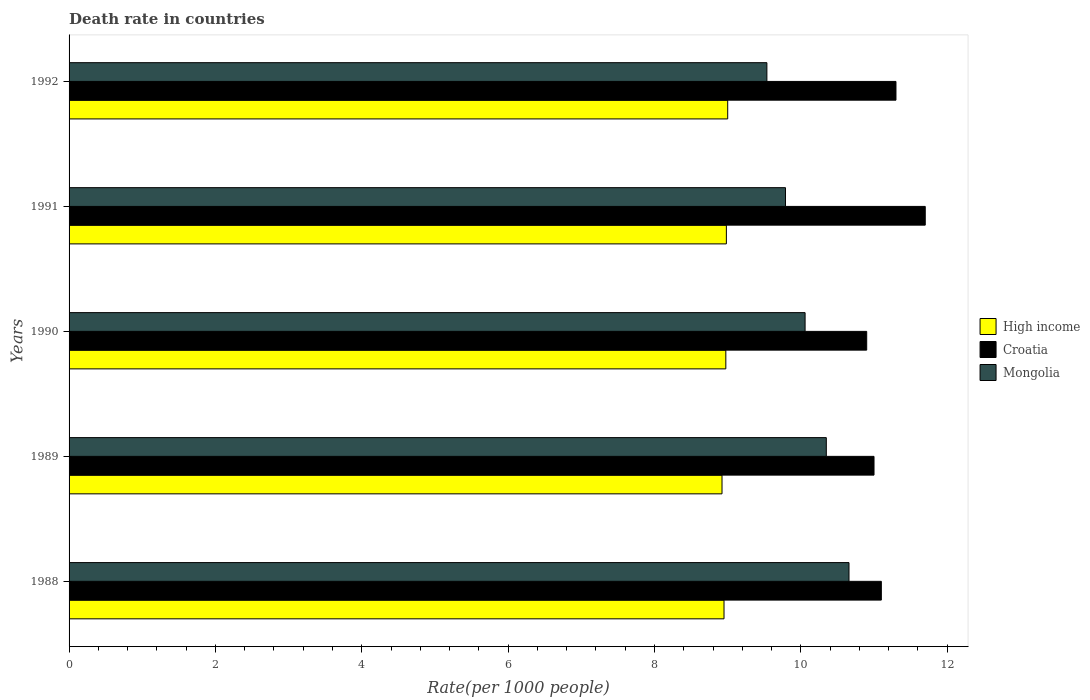How many different coloured bars are there?
Your response must be concise. 3. Are the number of bars per tick equal to the number of legend labels?
Keep it short and to the point. Yes. Are the number of bars on each tick of the Y-axis equal?
Ensure brevity in your answer.  Yes. How many bars are there on the 3rd tick from the top?
Ensure brevity in your answer.  3. How many bars are there on the 1st tick from the bottom?
Provide a succinct answer. 3. What is the label of the 1st group of bars from the top?
Provide a short and direct response. 1992. In how many cases, is the number of bars for a given year not equal to the number of legend labels?
Offer a terse response. 0. What is the death rate in Mongolia in 1992?
Ensure brevity in your answer.  9.54. Across all years, what is the maximum death rate in High income?
Your answer should be compact. 9. Across all years, what is the minimum death rate in Croatia?
Keep it short and to the point. 10.9. In which year was the death rate in Croatia maximum?
Provide a short and direct response. 1991. In which year was the death rate in Croatia minimum?
Keep it short and to the point. 1990. What is the total death rate in High income in the graph?
Make the answer very short. 44.83. What is the difference between the death rate in High income in 1988 and that in 1991?
Provide a short and direct response. -0.03. What is the difference between the death rate in Mongolia in 1990 and the death rate in High income in 1991?
Ensure brevity in your answer.  1.08. What is the average death rate in Mongolia per year?
Make the answer very short. 10.08. In the year 1988, what is the difference between the death rate in High income and death rate in Croatia?
Offer a terse response. -2.15. What is the ratio of the death rate in Mongolia in 1988 to that in 1991?
Your answer should be very brief. 1.09. What is the difference between the highest and the second highest death rate in Croatia?
Provide a short and direct response. 0.4. What is the difference between the highest and the lowest death rate in Croatia?
Make the answer very short. 0.8. In how many years, is the death rate in High income greater than the average death rate in High income taken over all years?
Ensure brevity in your answer.  3. What does the 1st bar from the top in 1990 represents?
Provide a short and direct response. Mongolia. What does the 3rd bar from the bottom in 1992 represents?
Make the answer very short. Mongolia. How many bars are there?
Your response must be concise. 15. How many years are there in the graph?
Your answer should be very brief. 5. What is the difference between two consecutive major ticks on the X-axis?
Your answer should be very brief. 2. Are the values on the major ticks of X-axis written in scientific E-notation?
Your answer should be compact. No. Does the graph contain any zero values?
Ensure brevity in your answer.  No. What is the title of the graph?
Keep it short and to the point. Death rate in countries. What is the label or title of the X-axis?
Ensure brevity in your answer.  Rate(per 1000 people). What is the label or title of the Y-axis?
Your answer should be very brief. Years. What is the Rate(per 1000 people) of High income in 1988?
Provide a succinct answer. 8.95. What is the Rate(per 1000 people) of Mongolia in 1988?
Provide a succinct answer. 10.66. What is the Rate(per 1000 people) of High income in 1989?
Provide a succinct answer. 8.92. What is the Rate(per 1000 people) in Croatia in 1989?
Offer a terse response. 11. What is the Rate(per 1000 people) of Mongolia in 1989?
Your answer should be compact. 10.35. What is the Rate(per 1000 people) in High income in 1990?
Ensure brevity in your answer.  8.97. What is the Rate(per 1000 people) of Mongolia in 1990?
Offer a terse response. 10.06. What is the Rate(per 1000 people) of High income in 1991?
Your answer should be compact. 8.98. What is the Rate(per 1000 people) in Mongolia in 1991?
Your answer should be very brief. 9.79. What is the Rate(per 1000 people) of High income in 1992?
Provide a succinct answer. 9. What is the Rate(per 1000 people) in Mongolia in 1992?
Provide a succinct answer. 9.54. Across all years, what is the maximum Rate(per 1000 people) in High income?
Give a very brief answer. 9. Across all years, what is the maximum Rate(per 1000 people) in Mongolia?
Offer a terse response. 10.66. Across all years, what is the minimum Rate(per 1000 people) in High income?
Your answer should be compact. 8.92. Across all years, what is the minimum Rate(per 1000 people) of Mongolia?
Ensure brevity in your answer.  9.54. What is the total Rate(per 1000 people) in High income in the graph?
Your response must be concise. 44.83. What is the total Rate(per 1000 people) in Croatia in the graph?
Offer a terse response. 56. What is the total Rate(per 1000 people) of Mongolia in the graph?
Your answer should be compact. 50.39. What is the difference between the Rate(per 1000 people) of High income in 1988 and that in 1989?
Provide a succinct answer. 0.03. What is the difference between the Rate(per 1000 people) in Croatia in 1988 and that in 1989?
Offer a terse response. 0.1. What is the difference between the Rate(per 1000 people) in Mongolia in 1988 and that in 1989?
Provide a short and direct response. 0.31. What is the difference between the Rate(per 1000 people) of High income in 1988 and that in 1990?
Provide a succinct answer. -0.02. What is the difference between the Rate(per 1000 people) in Mongolia in 1988 and that in 1990?
Offer a very short reply. 0.6. What is the difference between the Rate(per 1000 people) of High income in 1988 and that in 1991?
Your answer should be very brief. -0.03. What is the difference between the Rate(per 1000 people) of Croatia in 1988 and that in 1991?
Your answer should be very brief. -0.6. What is the difference between the Rate(per 1000 people) of Mongolia in 1988 and that in 1991?
Ensure brevity in your answer.  0.87. What is the difference between the Rate(per 1000 people) in High income in 1988 and that in 1992?
Your answer should be compact. -0.05. What is the difference between the Rate(per 1000 people) in Croatia in 1988 and that in 1992?
Your answer should be very brief. -0.2. What is the difference between the Rate(per 1000 people) in Mongolia in 1988 and that in 1992?
Your answer should be compact. 1.12. What is the difference between the Rate(per 1000 people) of High income in 1989 and that in 1990?
Your response must be concise. -0.05. What is the difference between the Rate(per 1000 people) in Mongolia in 1989 and that in 1990?
Make the answer very short. 0.29. What is the difference between the Rate(per 1000 people) in High income in 1989 and that in 1991?
Offer a very short reply. -0.06. What is the difference between the Rate(per 1000 people) in Mongolia in 1989 and that in 1991?
Ensure brevity in your answer.  0.56. What is the difference between the Rate(per 1000 people) of High income in 1989 and that in 1992?
Keep it short and to the point. -0.08. What is the difference between the Rate(per 1000 people) in Mongolia in 1989 and that in 1992?
Offer a very short reply. 0.81. What is the difference between the Rate(per 1000 people) in High income in 1990 and that in 1991?
Your answer should be compact. -0.01. What is the difference between the Rate(per 1000 people) of Croatia in 1990 and that in 1991?
Provide a succinct answer. -0.8. What is the difference between the Rate(per 1000 people) in Mongolia in 1990 and that in 1991?
Your response must be concise. 0.27. What is the difference between the Rate(per 1000 people) of High income in 1990 and that in 1992?
Make the answer very short. -0.03. What is the difference between the Rate(per 1000 people) of Croatia in 1990 and that in 1992?
Ensure brevity in your answer.  -0.4. What is the difference between the Rate(per 1000 people) of Mongolia in 1990 and that in 1992?
Make the answer very short. 0.52. What is the difference between the Rate(per 1000 people) in High income in 1991 and that in 1992?
Give a very brief answer. -0.02. What is the difference between the Rate(per 1000 people) in Mongolia in 1991 and that in 1992?
Make the answer very short. 0.25. What is the difference between the Rate(per 1000 people) of High income in 1988 and the Rate(per 1000 people) of Croatia in 1989?
Offer a terse response. -2.05. What is the difference between the Rate(per 1000 people) in High income in 1988 and the Rate(per 1000 people) in Mongolia in 1989?
Your answer should be very brief. -1.4. What is the difference between the Rate(per 1000 people) of Croatia in 1988 and the Rate(per 1000 people) of Mongolia in 1989?
Provide a short and direct response. 0.75. What is the difference between the Rate(per 1000 people) in High income in 1988 and the Rate(per 1000 people) in Croatia in 1990?
Make the answer very short. -1.95. What is the difference between the Rate(per 1000 people) of High income in 1988 and the Rate(per 1000 people) of Mongolia in 1990?
Keep it short and to the point. -1.11. What is the difference between the Rate(per 1000 people) in Croatia in 1988 and the Rate(per 1000 people) in Mongolia in 1990?
Provide a short and direct response. 1.04. What is the difference between the Rate(per 1000 people) in High income in 1988 and the Rate(per 1000 people) in Croatia in 1991?
Offer a very short reply. -2.75. What is the difference between the Rate(per 1000 people) in High income in 1988 and the Rate(per 1000 people) in Mongolia in 1991?
Keep it short and to the point. -0.84. What is the difference between the Rate(per 1000 people) in Croatia in 1988 and the Rate(per 1000 people) in Mongolia in 1991?
Offer a very short reply. 1.31. What is the difference between the Rate(per 1000 people) in High income in 1988 and the Rate(per 1000 people) in Croatia in 1992?
Offer a terse response. -2.35. What is the difference between the Rate(per 1000 people) of High income in 1988 and the Rate(per 1000 people) of Mongolia in 1992?
Give a very brief answer. -0.59. What is the difference between the Rate(per 1000 people) of Croatia in 1988 and the Rate(per 1000 people) of Mongolia in 1992?
Provide a short and direct response. 1.56. What is the difference between the Rate(per 1000 people) in High income in 1989 and the Rate(per 1000 people) in Croatia in 1990?
Give a very brief answer. -1.98. What is the difference between the Rate(per 1000 people) in High income in 1989 and the Rate(per 1000 people) in Mongolia in 1990?
Provide a short and direct response. -1.14. What is the difference between the Rate(per 1000 people) of Croatia in 1989 and the Rate(per 1000 people) of Mongolia in 1990?
Offer a terse response. 0.94. What is the difference between the Rate(per 1000 people) of High income in 1989 and the Rate(per 1000 people) of Croatia in 1991?
Ensure brevity in your answer.  -2.78. What is the difference between the Rate(per 1000 people) in High income in 1989 and the Rate(per 1000 people) in Mongolia in 1991?
Make the answer very short. -0.87. What is the difference between the Rate(per 1000 people) of Croatia in 1989 and the Rate(per 1000 people) of Mongolia in 1991?
Your answer should be compact. 1.21. What is the difference between the Rate(per 1000 people) of High income in 1989 and the Rate(per 1000 people) of Croatia in 1992?
Keep it short and to the point. -2.38. What is the difference between the Rate(per 1000 people) in High income in 1989 and the Rate(per 1000 people) in Mongolia in 1992?
Keep it short and to the point. -0.61. What is the difference between the Rate(per 1000 people) in Croatia in 1989 and the Rate(per 1000 people) in Mongolia in 1992?
Your answer should be compact. 1.46. What is the difference between the Rate(per 1000 people) in High income in 1990 and the Rate(per 1000 people) in Croatia in 1991?
Your answer should be compact. -2.73. What is the difference between the Rate(per 1000 people) of High income in 1990 and the Rate(per 1000 people) of Mongolia in 1991?
Your answer should be compact. -0.82. What is the difference between the Rate(per 1000 people) of Croatia in 1990 and the Rate(per 1000 people) of Mongolia in 1991?
Your response must be concise. 1.11. What is the difference between the Rate(per 1000 people) in High income in 1990 and the Rate(per 1000 people) in Croatia in 1992?
Provide a succinct answer. -2.33. What is the difference between the Rate(per 1000 people) in High income in 1990 and the Rate(per 1000 people) in Mongolia in 1992?
Your response must be concise. -0.56. What is the difference between the Rate(per 1000 people) in Croatia in 1990 and the Rate(per 1000 people) in Mongolia in 1992?
Provide a short and direct response. 1.36. What is the difference between the Rate(per 1000 people) in High income in 1991 and the Rate(per 1000 people) in Croatia in 1992?
Give a very brief answer. -2.32. What is the difference between the Rate(per 1000 people) in High income in 1991 and the Rate(per 1000 people) in Mongolia in 1992?
Offer a very short reply. -0.55. What is the difference between the Rate(per 1000 people) of Croatia in 1991 and the Rate(per 1000 people) of Mongolia in 1992?
Keep it short and to the point. 2.16. What is the average Rate(per 1000 people) of High income per year?
Give a very brief answer. 8.97. What is the average Rate(per 1000 people) of Croatia per year?
Offer a terse response. 11.2. What is the average Rate(per 1000 people) of Mongolia per year?
Your response must be concise. 10.08. In the year 1988, what is the difference between the Rate(per 1000 people) of High income and Rate(per 1000 people) of Croatia?
Your response must be concise. -2.15. In the year 1988, what is the difference between the Rate(per 1000 people) of High income and Rate(per 1000 people) of Mongolia?
Provide a succinct answer. -1.71. In the year 1988, what is the difference between the Rate(per 1000 people) of Croatia and Rate(per 1000 people) of Mongolia?
Your answer should be very brief. 0.44. In the year 1989, what is the difference between the Rate(per 1000 people) of High income and Rate(per 1000 people) of Croatia?
Provide a short and direct response. -2.08. In the year 1989, what is the difference between the Rate(per 1000 people) of High income and Rate(per 1000 people) of Mongolia?
Offer a very short reply. -1.43. In the year 1989, what is the difference between the Rate(per 1000 people) in Croatia and Rate(per 1000 people) in Mongolia?
Give a very brief answer. 0.65. In the year 1990, what is the difference between the Rate(per 1000 people) of High income and Rate(per 1000 people) of Croatia?
Give a very brief answer. -1.93. In the year 1990, what is the difference between the Rate(per 1000 people) in High income and Rate(per 1000 people) in Mongolia?
Make the answer very short. -1.08. In the year 1990, what is the difference between the Rate(per 1000 people) of Croatia and Rate(per 1000 people) of Mongolia?
Your answer should be very brief. 0.84. In the year 1991, what is the difference between the Rate(per 1000 people) of High income and Rate(per 1000 people) of Croatia?
Offer a very short reply. -2.72. In the year 1991, what is the difference between the Rate(per 1000 people) in High income and Rate(per 1000 people) in Mongolia?
Provide a succinct answer. -0.81. In the year 1991, what is the difference between the Rate(per 1000 people) in Croatia and Rate(per 1000 people) in Mongolia?
Provide a succinct answer. 1.91. In the year 1992, what is the difference between the Rate(per 1000 people) in High income and Rate(per 1000 people) in Croatia?
Keep it short and to the point. -2.3. In the year 1992, what is the difference between the Rate(per 1000 people) of High income and Rate(per 1000 people) of Mongolia?
Provide a succinct answer. -0.54. In the year 1992, what is the difference between the Rate(per 1000 people) in Croatia and Rate(per 1000 people) in Mongolia?
Offer a terse response. 1.76. What is the ratio of the Rate(per 1000 people) in Croatia in 1988 to that in 1989?
Provide a short and direct response. 1.01. What is the ratio of the Rate(per 1000 people) in Croatia in 1988 to that in 1990?
Provide a short and direct response. 1.02. What is the ratio of the Rate(per 1000 people) in Mongolia in 1988 to that in 1990?
Your response must be concise. 1.06. What is the ratio of the Rate(per 1000 people) in High income in 1988 to that in 1991?
Your response must be concise. 1. What is the ratio of the Rate(per 1000 people) in Croatia in 1988 to that in 1991?
Ensure brevity in your answer.  0.95. What is the ratio of the Rate(per 1000 people) in Mongolia in 1988 to that in 1991?
Your answer should be compact. 1.09. What is the ratio of the Rate(per 1000 people) in High income in 1988 to that in 1992?
Provide a short and direct response. 0.99. What is the ratio of the Rate(per 1000 people) in Croatia in 1988 to that in 1992?
Give a very brief answer. 0.98. What is the ratio of the Rate(per 1000 people) of Mongolia in 1988 to that in 1992?
Give a very brief answer. 1.12. What is the ratio of the Rate(per 1000 people) of High income in 1989 to that in 1990?
Your answer should be compact. 0.99. What is the ratio of the Rate(per 1000 people) of Croatia in 1989 to that in 1990?
Ensure brevity in your answer.  1.01. What is the ratio of the Rate(per 1000 people) in Mongolia in 1989 to that in 1990?
Your answer should be compact. 1.03. What is the ratio of the Rate(per 1000 people) of Croatia in 1989 to that in 1991?
Your response must be concise. 0.94. What is the ratio of the Rate(per 1000 people) in Mongolia in 1989 to that in 1991?
Keep it short and to the point. 1.06. What is the ratio of the Rate(per 1000 people) of Croatia in 1989 to that in 1992?
Ensure brevity in your answer.  0.97. What is the ratio of the Rate(per 1000 people) of Mongolia in 1989 to that in 1992?
Offer a terse response. 1.09. What is the ratio of the Rate(per 1000 people) of Croatia in 1990 to that in 1991?
Your response must be concise. 0.93. What is the ratio of the Rate(per 1000 people) of Mongolia in 1990 to that in 1991?
Offer a very short reply. 1.03. What is the ratio of the Rate(per 1000 people) of High income in 1990 to that in 1992?
Give a very brief answer. 1. What is the ratio of the Rate(per 1000 people) in Croatia in 1990 to that in 1992?
Ensure brevity in your answer.  0.96. What is the ratio of the Rate(per 1000 people) in Mongolia in 1990 to that in 1992?
Make the answer very short. 1.05. What is the ratio of the Rate(per 1000 people) in Croatia in 1991 to that in 1992?
Provide a succinct answer. 1.04. What is the ratio of the Rate(per 1000 people) in Mongolia in 1991 to that in 1992?
Your answer should be compact. 1.03. What is the difference between the highest and the second highest Rate(per 1000 people) of High income?
Offer a terse response. 0.02. What is the difference between the highest and the second highest Rate(per 1000 people) of Mongolia?
Your response must be concise. 0.31. What is the difference between the highest and the lowest Rate(per 1000 people) of High income?
Offer a terse response. 0.08. What is the difference between the highest and the lowest Rate(per 1000 people) in Mongolia?
Provide a succinct answer. 1.12. 